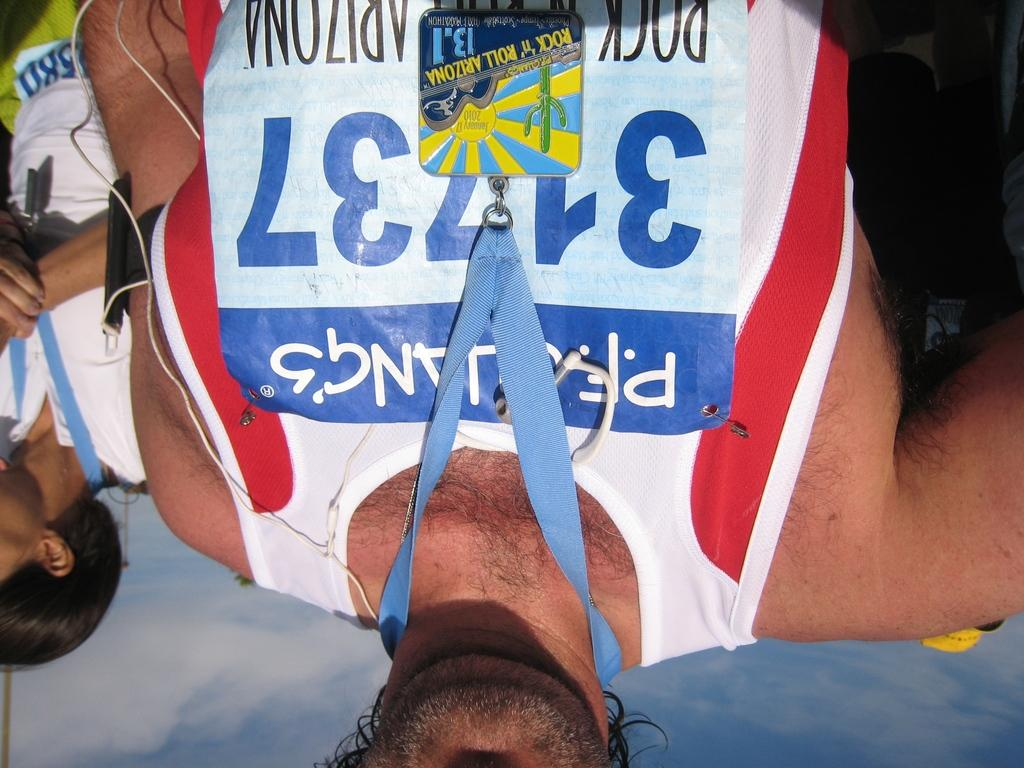<image>
Describe the image concisely. Man wearing a tag and the number 31737 on his chest. 